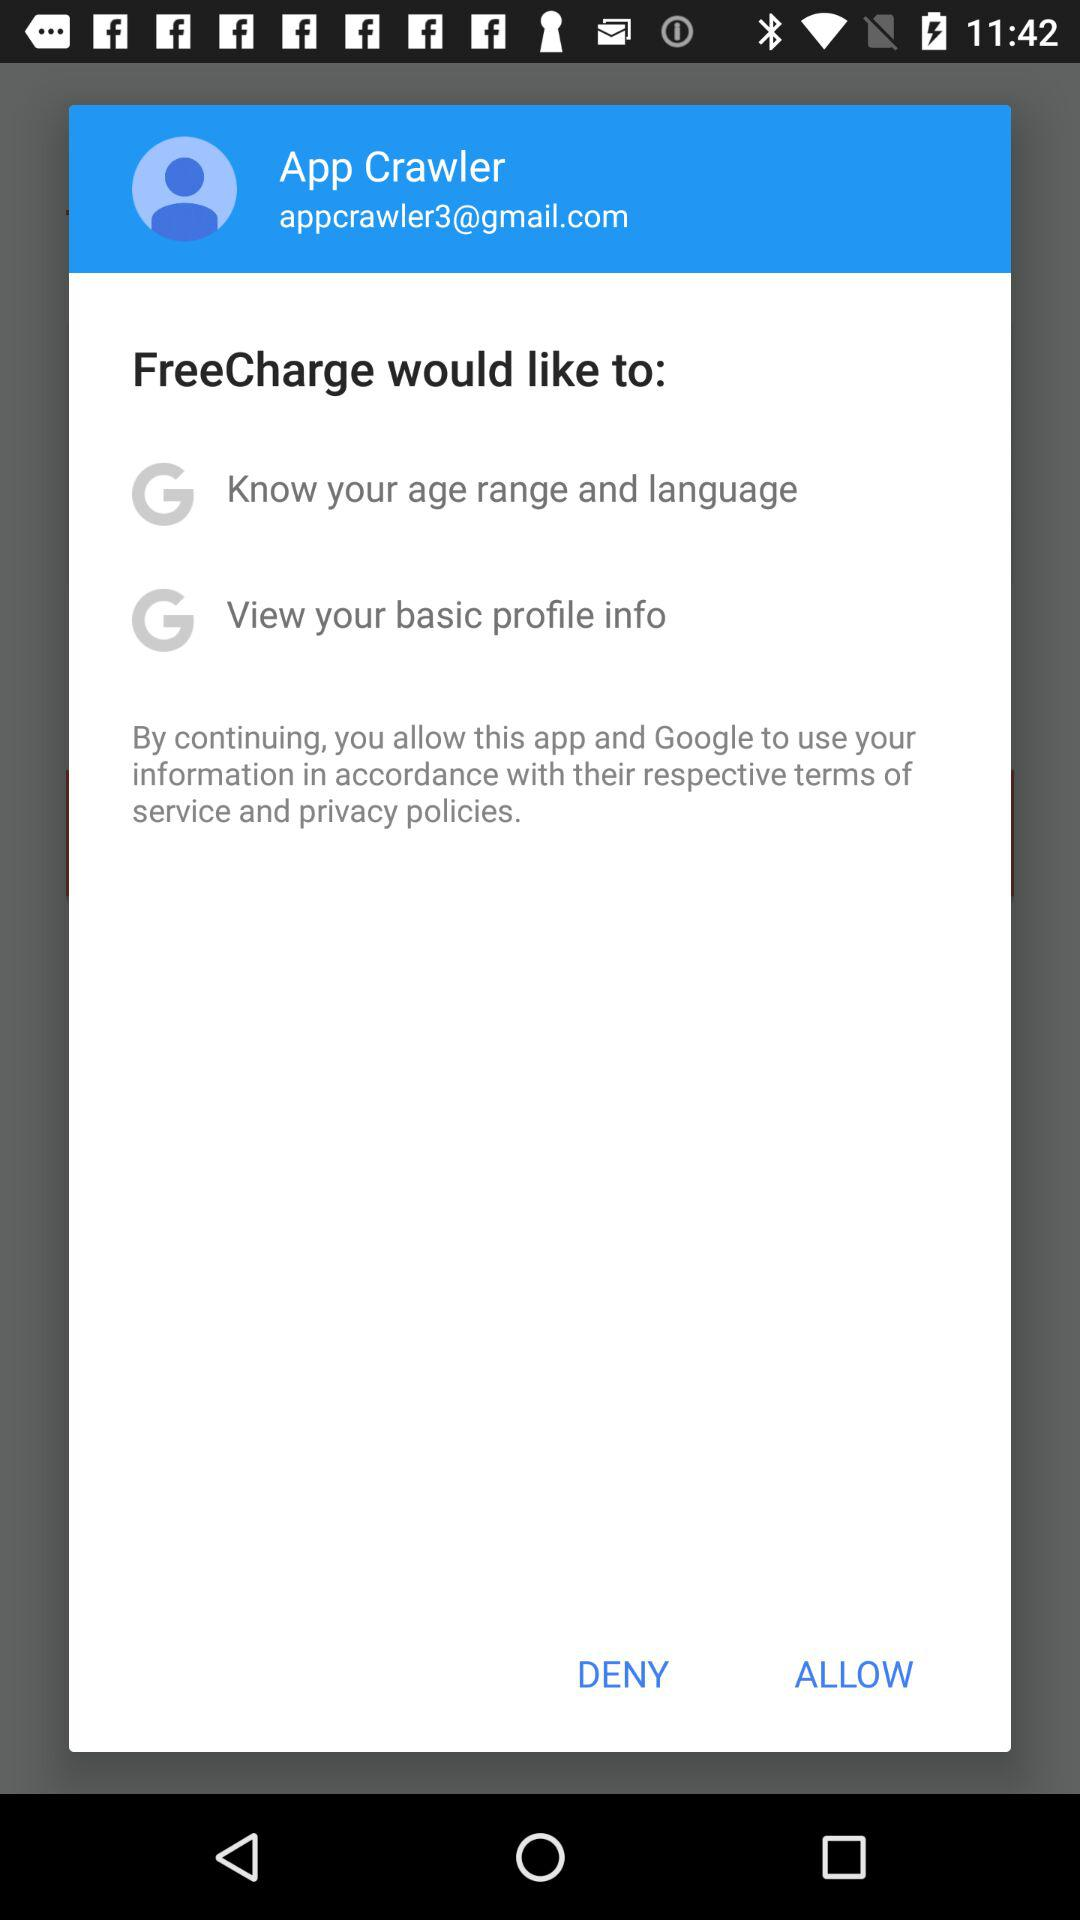What is the name of the user? The name of the user is App Crawler. 